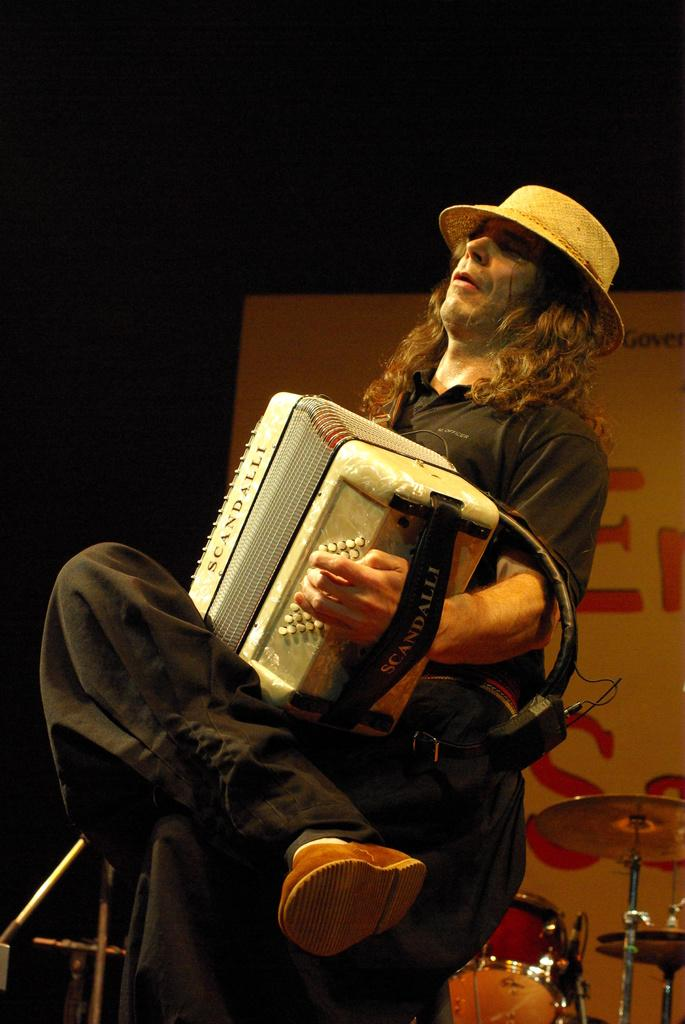What is the person in the image doing? The person is playing a musical instrument. What is the person wearing in the image? The person is wearing a black dress. What is the person sitting on in the image? The person is sitting on a chair. What can be seen in the background of the image? There are drums and a board in the background of the image. What type of juice is the person drinking in the image? There is no juice present in the image; the person is playing a musical instrument. What word is written on the board in the background of the image? There is no word visible on the board in the background of the image. 